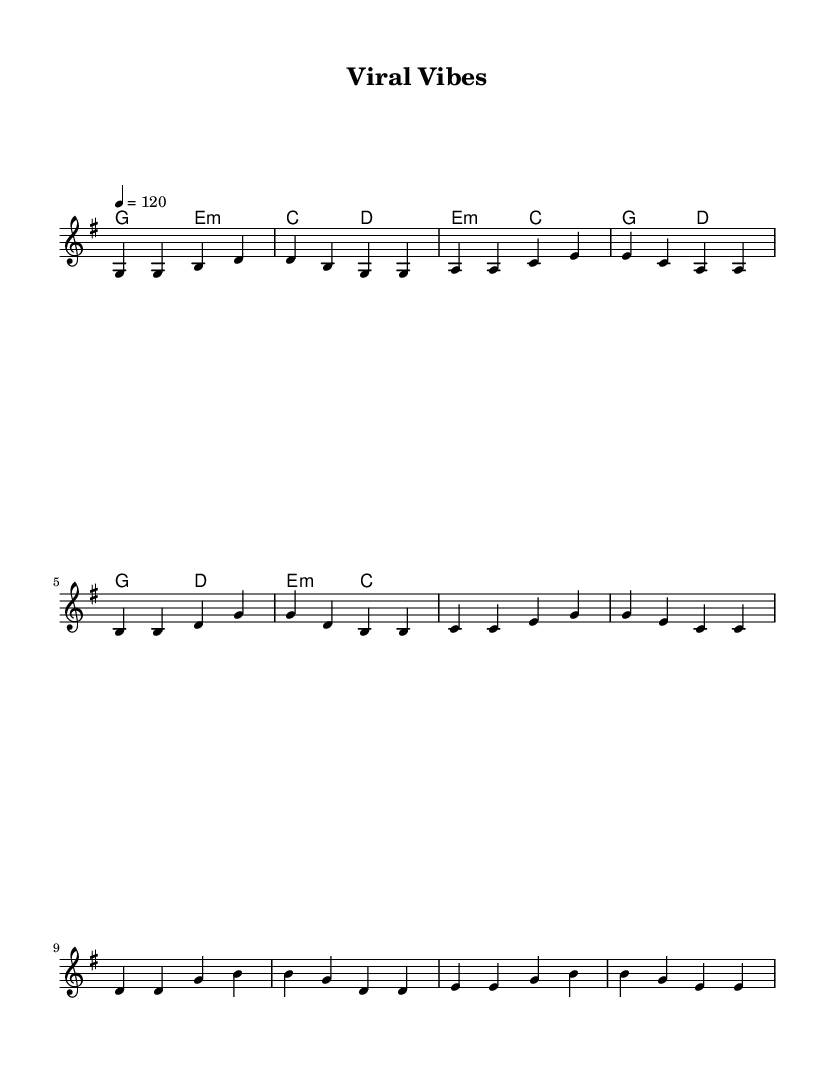What is the key signature of this music? The key signature is indicated at the beginning of the score. It shows one sharp, which is characteristic of G major.
Answer: G major What is the time signature of this piece? The time signature is shown at the beginning of the score, which indicates that there are four beats per measure in a common rhythm for folk music.
Answer: 4/4 What is the tempo marking for this piece? The tempo marking is specified at the beginning of the score and indicates that the piece should be played at a speed of 120 beats per minute.
Answer: 120 How many lines are in the melody staff? A standard music staff has five lines, and the melody is written on this staff, so there are five lines in the melody staff.
Answer: 5 What is the structure of the lyrics in this song? The lyrics are divided into three main sections: verse, pre-chorus, and chorus, which is a common structure in popular music, especially in folk-pop.
Answer: Verse, Pre-Chorus, Chorus What type of chords are used in the verse? The verse features simple triads, which are common in folk music to provide a harmonic foundation for the melody. The chords are G major and E minor.
Answer: G major, E minor What is the primary theme of the lyrics? The lyrics convey themes of social media excitement and the pursuit of viral fame, which align with the modern folk-pop genre reflecting contemporary culture.
Answer: Viral Fame 